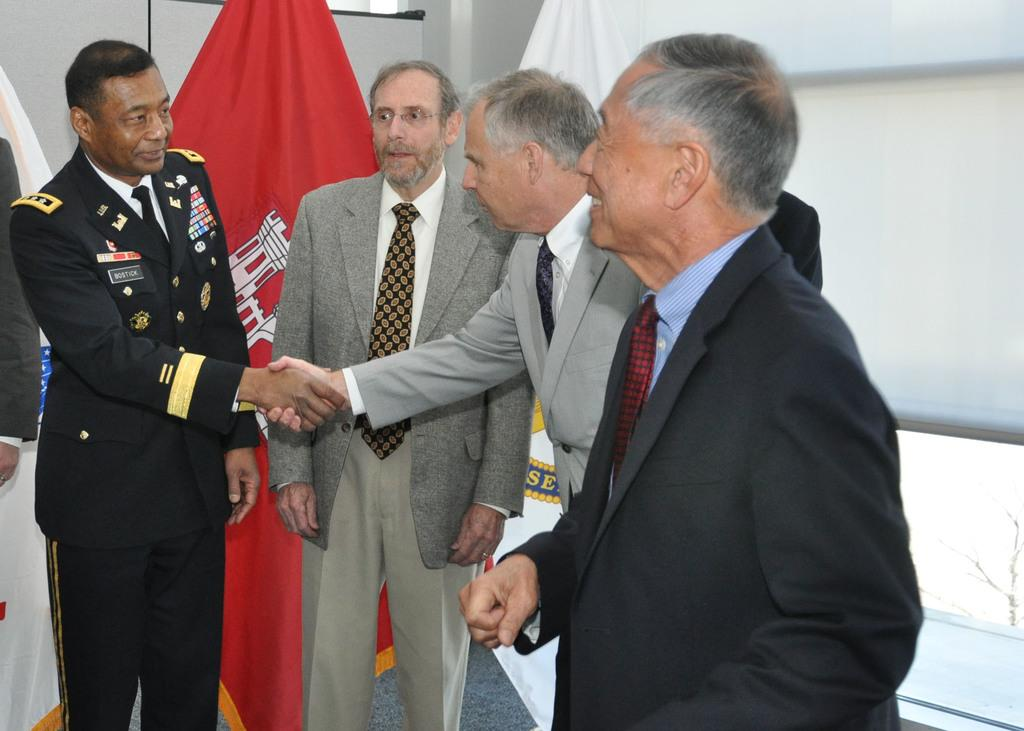What is happening in the image involving the group of people? Two men are shaking hands in the image. What else can be seen in the image besides the group of people? There is a flag visible in the image. What type of cable is being used by the group of people in the image? There is no cable visible in the image. Where is the lunchroom located in the image? There is no lunchroom present in the image. 